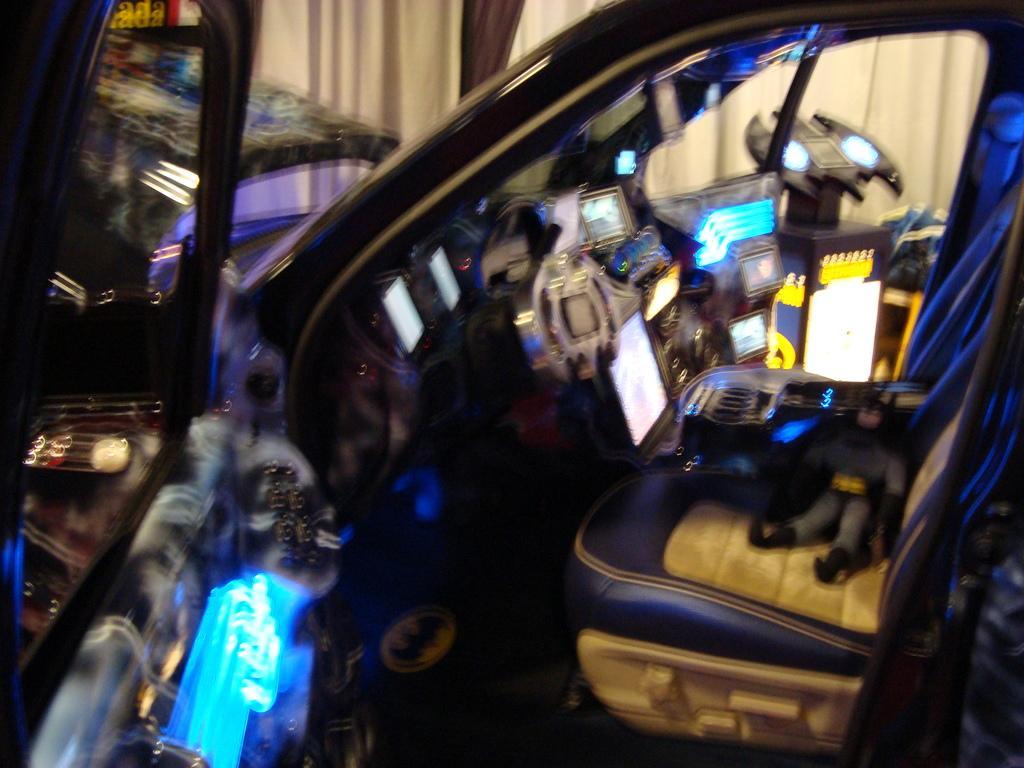Please provide a concise description of this image. In this image I can see black color thing and few other stuffs. I can see this image is little bit blurry. 